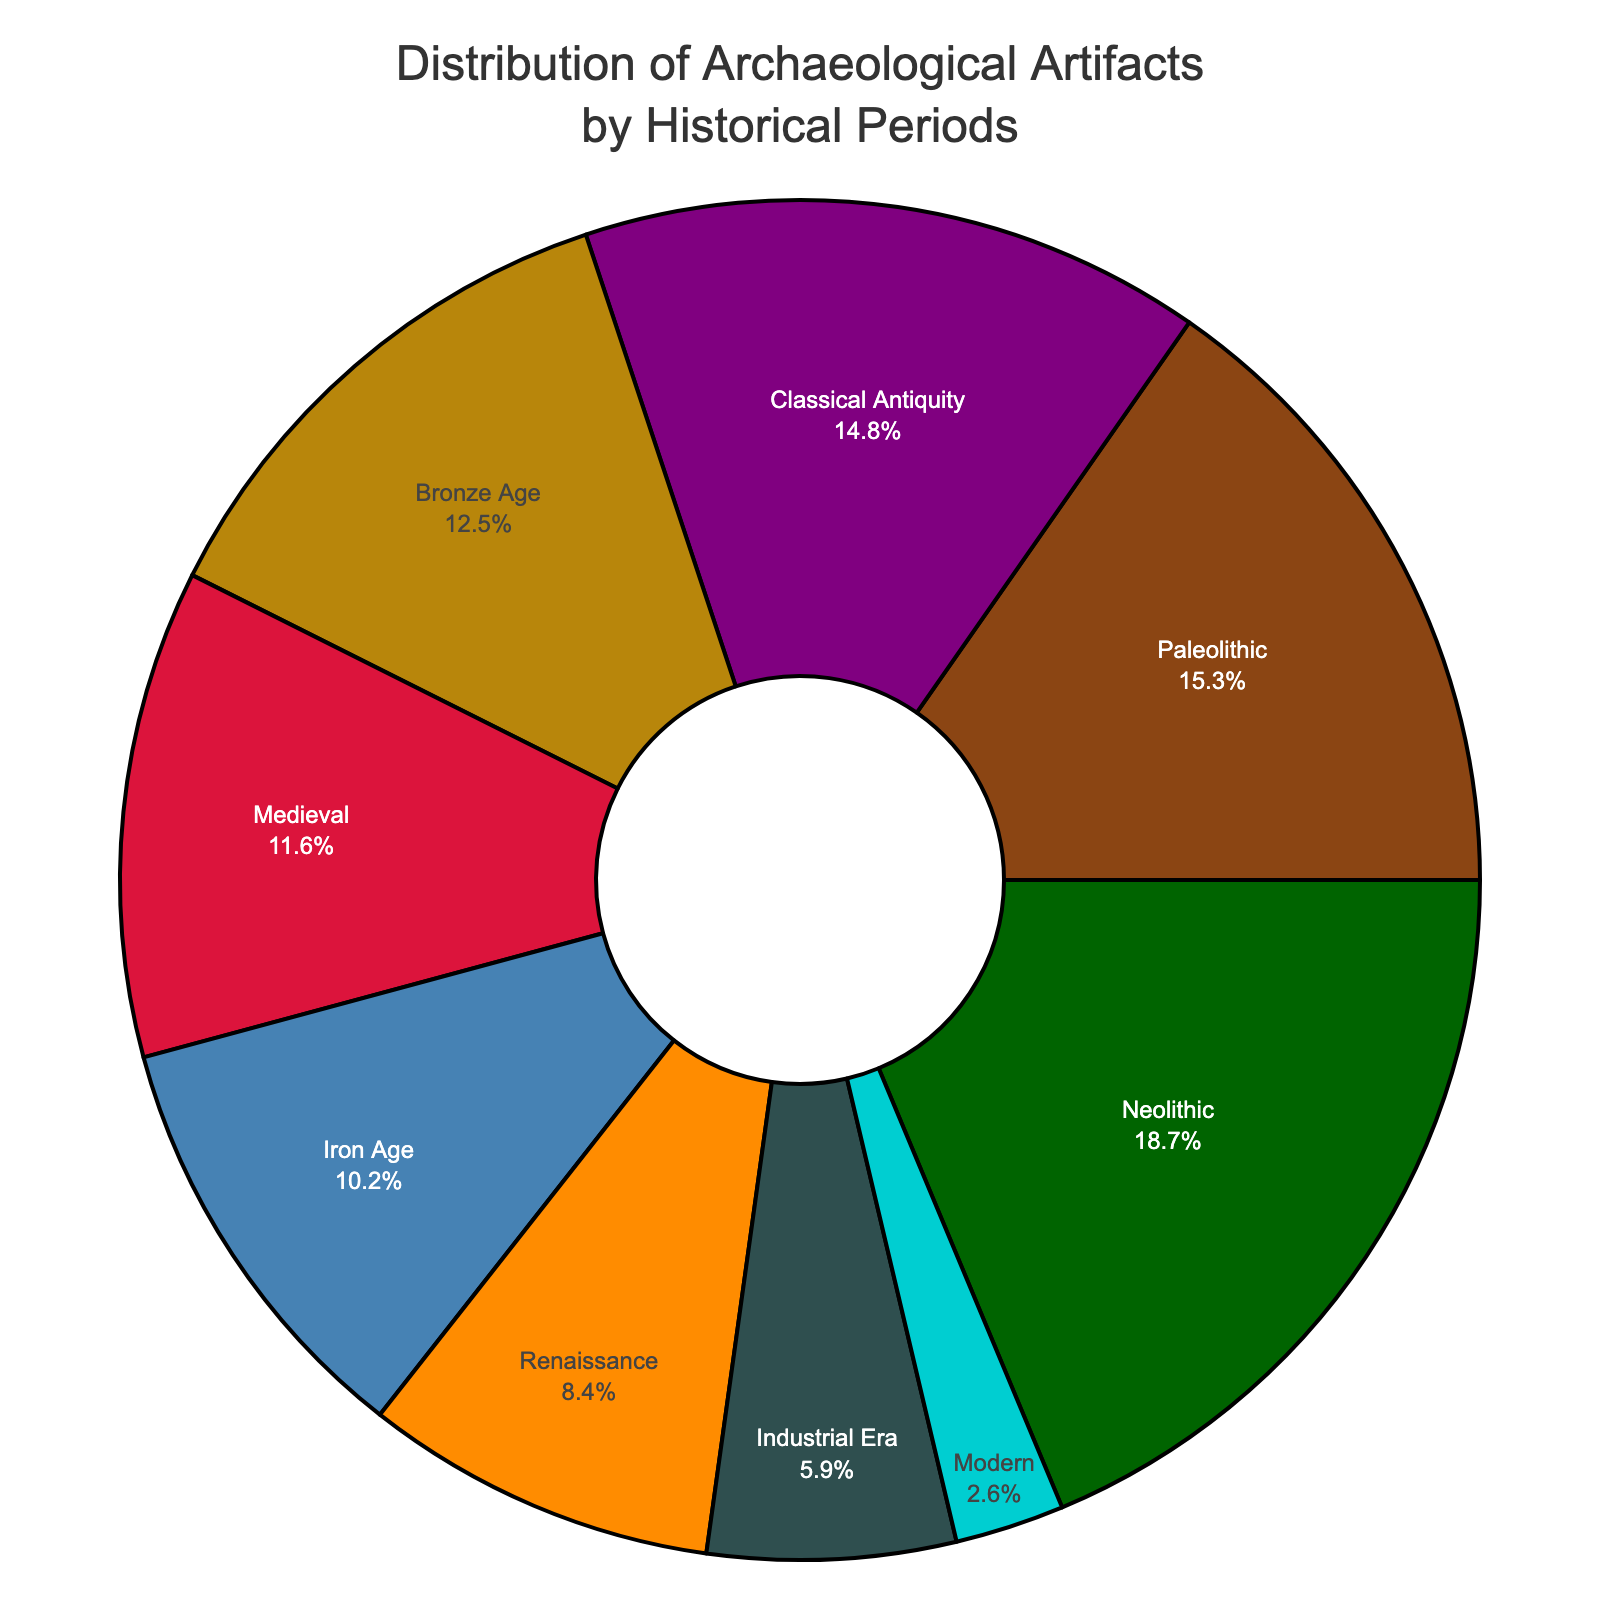What is the most represented historical period in the museum's collection? From the pie chart, the segment with the largest percentage represents the historical period with the most artifacts. In this case, it is the Neolithic period with 18.7%.
Answer: Neolithic period Which two historical periods have the smallest percentages in the collection, and what are their combined percentages? The two smallest segments in the pie chart represent the Modern period and the Industrial Era, with 2.6% and 5.9% respectively. Adding these gives 2.6 + 5.9 = 8.5%.
Answer: Modern and Industrial Era, 8.5% How does the percentage of artifacts from the Bronze Age compare to those from the Classical Antiquity? By comparing the sizes of the segments, the Bronze Age has 12.5% while Classical Antiquity has 14.8%. Thus, the Classical Antiquity percentage is larger.
Answer: Classical Antiquity is larger If you combine the percentages of the Paleolithic and Medieval periods, how does this compare to the percentage of the Neolithic period? Adding the Paleolithic (15.3%) and Medieval (11.6%) gives 15.3 + 11.6 = 26.9%. This combined percentage is greater than the Neolithic period (18.7%).
Answer: Combined percentage is greater What is the difference in archaeological artifact percentages between the Iron Age and the Renaissance periods? The pie chart shows the Iron Age with 10.2% and the Renaissance with 8.4%. The difference is 10.2 - 8.4 = 1.8%.
Answer: 1.8% What historical period is represented by the blue color and what is its percentage? Observing the pie chart's color coding, the segment colored in blue represents the Bronze Age, which has a percentage of 12.5%.
Answer: Bronze Age, 12.5% What is the combined percentage of artifacts from the Renaissance and Industrial Era periods, and does it surpass 15%? Summing the percentages of the Renaissance (8.4%) and Industrial Era (5.9%) yields 8.4 + 5.9 = 14.3%. This total is less than 15%.
Answer: 14.3%, does not surpass 15% Among the Paleolithic, Neolithic, and Medieval periods, which one has the middle value in terms of artifact percentage? The percentages of these periods are Paleolithic (15.3%), Neolithic (18.7%), and Medieval (11.6%). Sorting these values, 11.6, 15.3, 18.7, the middle value is 15.3%, which belongs to the Paleolithic period.
Answer: Paleolithic period 